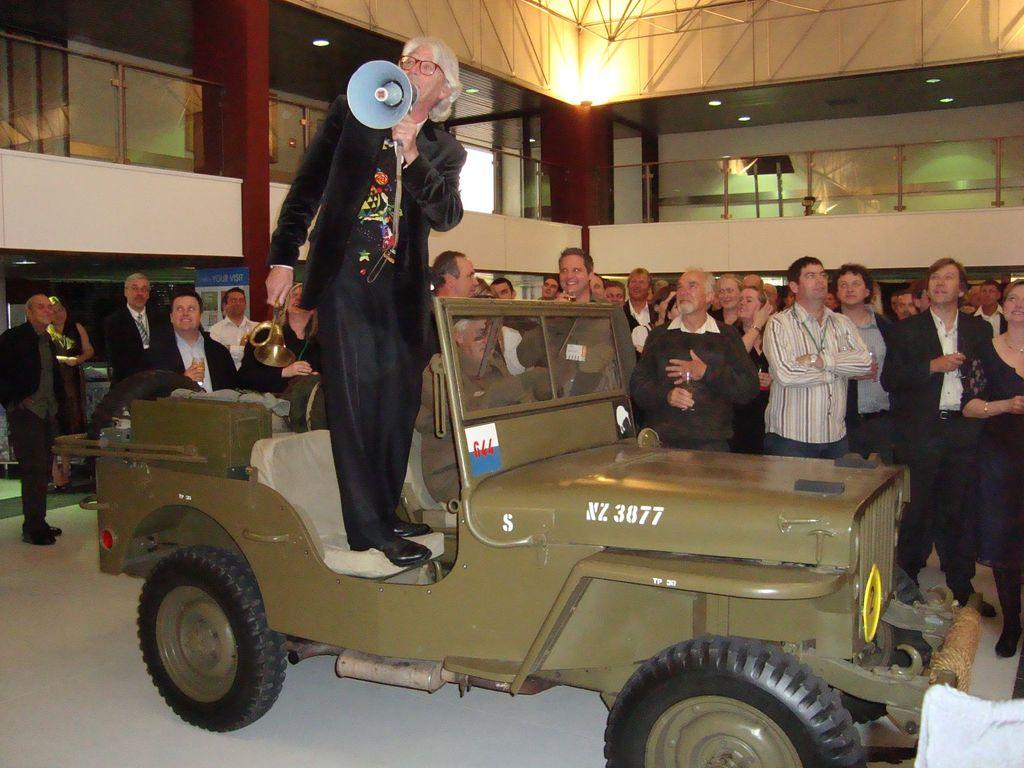What is the person in the image doing? The person is standing on the seat of a car in the image. What object is the person holding? The person is holding a megaphone. What can be seen in the background of the image? There is a group of people standing and lights visible in the background of the image. What type of ice can be seen melting on the car's hood in the image? There is no ice visible on the car's hood in the image. What kind of bat is flying around the person holding the megaphone in the image? There are no bats present in the image. 